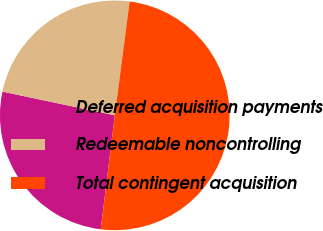Convert chart. <chart><loc_0><loc_0><loc_500><loc_500><pie_chart><fcel>Deferred acquisition payments<fcel>Redeemable noncontrolling<fcel>Total contingent acquisition<nl><fcel>26.36%<fcel>23.75%<fcel>49.89%<nl></chart> 